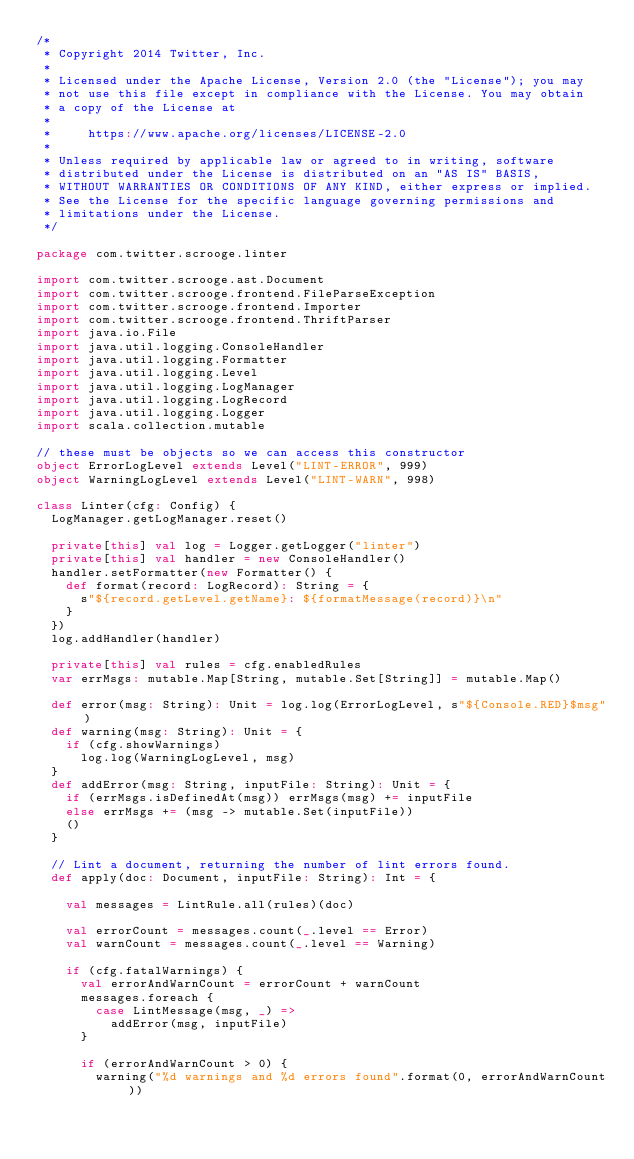Convert code to text. <code><loc_0><loc_0><loc_500><loc_500><_Scala_>/*
 * Copyright 2014 Twitter, Inc.
 *
 * Licensed under the Apache License, Version 2.0 (the "License"); you may
 * not use this file except in compliance with the License. You may obtain
 * a copy of the License at
 *
 *     https://www.apache.org/licenses/LICENSE-2.0
 *
 * Unless required by applicable law or agreed to in writing, software
 * distributed under the License is distributed on an "AS IS" BASIS,
 * WITHOUT WARRANTIES OR CONDITIONS OF ANY KIND, either express or implied.
 * See the License for the specific language governing permissions and
 * limitations under the License.
 */

package com.twitter.scrooge.linter

import com.twitter.scrooge.ast.Document
import com.twitter.scrooge.frontend.FileParseException
import com.twitter.scrooge.frontend.Importer
import com.twitter.scrooge.frontend.ThriftParser
import java.io.File
import java.util.logging.ConsoleHandler
import java.util.logging.Formatter
import java.util.logging.Level
import java.util.logging.LogManager
import java.util.logging.LogRecord
import java.util.logging.Logger
import scala.collection.mutable

// these must be objects so we can access this constructor
object ErrorLogLevel extends Level("LINT-ERROR", 999)
object WarningLogLevel extends Level("LINT-WARN", 998)

class Linter(cfg: Config) {
  LogManager.getLogManager.reset()

  private[this] val log = Logger.getLogger("linter")
  private[this] val handler = new ConsoleHandler()
  handler.setFormatter(new Formatter() {
    def format(record: LogRecord): String = {
      s"${record.getLevel.getName}: ${formatMessage(record)}\n"
    }
  })
  log.addHandler(handler)

  private[this] val rules = cfg.enabledRules
  var errMsgs: mutable.Map[String, mutable.Set[String]] = mutable.Map()

  def error(msg: String): Unit = log.log(ErrorLogLevel, s"${Console.RED}$msg")
  def warning(msg: String): Unit = {
    if (cfg.showWarnings)
      log.log(WarningLogLevel, msg)
  }
  def addError(msg: String, inputFile: String): Unit = {
    if (errMsgs.isDefinedAt(msg)) errMsgs(msg) += inputFile
    else errMsgs += (msg -> mutable.Set(inputFile))
    ()
  }

  // Lint a document, returning the number of lint errors found.
  def apply(doc: Document, inputFile: String): Int = {

    val messages = LintRule.all(rules)(doc)

    val errorCount = messages.count(_.level == Error)
    val warnCount = messages.count(_.level == Warning)

    if (cfg.fatalWarnings) {
      val errorAndWarnCount = errorCount + warnCount
      messages.foreach {
        case LintMessage(msg, _) =>
          addError(msg, inputFile)
      }

      if (errorAndWarnCount > 0) {
        warning("%d warnings and %d errors found".format(0, errorAndWarnCount))</code> 